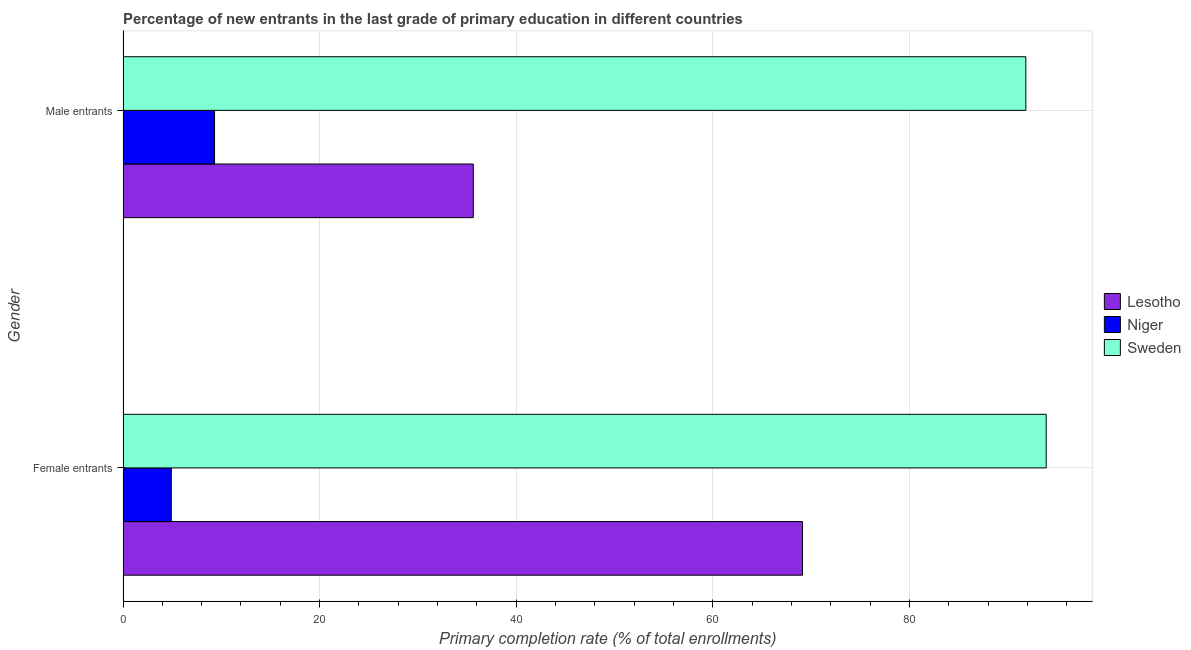How many different coloured bars are there?
Provide a short and direct response. 3. How many groups of bars are there?
Your answer should be very brief. 2. Are the number of bars per tick equal to the number of legend labels?
Keep it short and to the point. Yes. Are the number of bars on each tick of the Y-axis equal?
Provide a short and direct response. Yes. How many bars are there on the 2nd tick from the top?
Make the answer very short. 3. How many bars are there on the 1st tick from the bottom?
Give a very brief answer. 3. What is the label of the 1st group of bars from the top?
Provide a short and direct response. Male entrants. What is the primary completion rate of male entrants in Niger?
Make the answer very short. 9.31. Across all countries, what is the maximum primary completion rate of male entrants?
Ensure brevity in your answer.  91.83. Across all countries, what is the minimum primary completion rate of female entrants?
Your response must be concise. 4.91. In which country was the primary completion rate of male entrants maximum?
Offer a terse response. Sweden. In which country was the primary completion rate of female entrants minimum?
Give a very brief answer. Niger. What is the total primary completion rate of female entrants in the graph?
Make the answer very short. 167.92. What is the difference between the primary completion rate of male entrants in Lesotho and that in Niger?
Your answer should be compact. 26.32. What is the difference between the primary completion rate of female entrants in Sweden and the primary completion rate of male entrants in Niger?
Your answer should be very brief. 84.59. What is the average primary completion rate of female entrants per country?
Your answer should be compact. 55.97. What is the difference between the primary completion rate of female entrants and primary completion rate of male entrants in Sweden?
Provide a short and direct response. 2.07. In how many countries, is the primary completion rate of male entrants greater than 60 %?
Provide a short and direct response. 1. What is the ratio of the primary completion rate of female entrants in Lesotho to that in Sweden?
Keep it short and to the point. 0.74. What does the 1st bar from the top in Female entrants represents?
Provide a succinct answer. Sweden. What does the 2nd bar from the bottom in Male entrants represents?
Your answer should be compact. Niger. How many bars are there?
Provide a succinct answer. 6. What is the difference between two consecutive major ticks on the X-axis?
Your answer should be compact. 20. Are the values on the major ticks of X-axis written in scientific E-notation?
Give a very brief answer. No. How are the legend labels stacked?
Your response must be concise. Vertical. What is the title of the graph?
Your response must be concise. Percentage of new entrants in the last grade of primary education in different countries. What is the label or title of the X-axis?
Offer a terse response. Primary completion rate (% of total enrollments). What is the Primary completion rate (% of total enrollments) in Lesotho in Female entrants?
Keep it short and to the point. 69.11. What is the Primary completion rate (% of total enrollments) of Niger in Female entrants?
Offer a very short reply. 4.91. What is the Primary completion rate (% of total enrollments) of Sweden in Female entrants?
Make the answer very short. 93.9. What is the Primary completion rate (% of total enrollments) in Lesotho in Male entrants?
Provide a short and direct response. 35.63. What is the Primary completion rate (% of total enrollments) in Niger in Male entrants?
Offer a terse response. 9.31. What is the Primary completion rate (% of total enrollments) in Sweden in Male entrants?
Your answer should be compact. 91.83. Across all Gender, what is the maximum Primary completion rate (% of total enrollments) of Lesotho?
Your answer should be very brief. 69.11. Across all Gender, what is the maximum Primary completion rate (% of total enrollments) in Niger?
Offer a very short reply. 9.31. Across all Gender, what is the maximum Primary completion rate (% of total enrollments) of Sweden?
Your response must be concise. 93.9. Across all Gender, what is the minimum Primary completion rate (% of total enrollments) of Lesotho?
Provide a succinct answer. 35.63. Across all Gender, what is the minimum Primary completion rate (% of total enrollments) of Niger?
Keep it short and to the point. 4.91. Across all Gender, what is the minimum Primary completion rate (% of total enrollments) of Sweden?
Your response must be concise. 91.83. What is the total Primary completion rate (% of total enrollments) in Lesotho in the graph?
Give a very brief answer. 104.74. What is the total Primary completion rate (% of total enrollments) of Niger in the graph?
Provide a short and direct response. 14.22. What is the total Primary completion rate (% of total enrollments) of Sweden in the graph?
Your response must be concise. 185.73. What is the difference between the Primary completion rate (% of total enrollments) in Lesotho in Female entrants and that in Male entrants?
Give a very brief answer. 33.48. What is the difference between the Primary completion rate (% of total enrollments) in Niger in Female entrants and that in Male entrants?
Give a very brief answer. -4.4. What is the difference between the Primary completion rate (% of total enrollments) in Sweden in Female entrants and that in Male entrants?
Keep it short and to the point. 2.07. What is the difference between the Primary completion rate (% of total enrollments) of Lesotho in Female entrants and the Primary completion rate (% of total enrollments) of Niger in Male entrants?
Give a very brief answer. 59.8. What is the difference between the Primary completion rate (% of total enrollments) in Lesotho in Female entrants and the Primary completion rate (% of total enrollments) in Sweden in Male entrants?
Offer a very short reply. -22.71. What is the difference between the Primary completion rate (% of total enrollments) in Niger in Female entrants and the Primary completion rate (% of total enrollments) in Sweden in Male entrants?
Make the answer very short. -86.91. What is the average Primary completion rate (% of total enrollments) of Lesotho per Gender?
Provide a succinct answer. 52.37. What is the average Primary completion rate (% of total enrollments) of Niger per Gender?
Your answer should be very brief. 7.11. What is the average Primary completion rate (% of total enrollments) of Sweden per Gender?
Ensure brevity in your answer.  92.86. What is the difference between the Primary completion rate (% of total enrollments) of Lesotho and Primary completion rate (% of total enrollments) of Niger in Female entrants?
Provide a succinct answer. 64.2. What is the difference between the Primary completion rate (% of total enrollments) in Lesotho and Primary completion rate (% of total enrollments) in Sweden in Female entrants?
Offer a terse response. -24.79. What is the difference between the Primary completion rate (% of total enrollments) in Niger and Primary completion rate (% of total enrollments) in Sweden in Female entrants?
Make the answer very short. -88.99. What is the difference between the Primary completion rate (% of total enrollments) in Lesotho and Primary completion rate (% of total enrollments) in Niger in Male entrants?
Offer a very short reply. 26.32. What is the difference between the Primary completion rate (% of total enrollments) of Lesotho and Primary completion rate (% of total enrollments) of Sweden in Male entrants?
Keep it short and to the point. -56.2. What is the difference between the Primary completion rate (% of total enrollments) of Niger and Primary completion rate (% of total enrollments) of Sweden in Male entrants?
Your answer should be compact. -82.52. What is the ratio of the Primary completion rate (% of total enrollments) of Lesotho in Female entrants to that in Male entrants?
Offer a terse response. 1.94. What is the ratio of the Primary completion rate (% of total enrollments) of Niger in Female entrants to that in Male entrants?
Your answer should be very brief. 0.53. What is the ratio of the Primary completion rate (% of total enrollments) of Sweden in Female entrants to that in Male entrants?
Provide a short and direct response. 1.02. What is the difference between the highest and the second highest Primary completion rate (% of total enrollments) in Lesotho?
Give a very brief answer. 33.48. What is the difference between the highest and the second highest Primary completion rate (% of total enrollments) in Niger?
Provide a succinct answer. 4.4. What is the difference between the highest and the second highest Primary completion rate (% of total enrollments) of Sweden?
Give a very brief answer. 2.07. What is the difference between the highest and the lowest Primary completion rate (% of total enrollments) of Lesotho?
Ensure brevity in your answer.  33.48. What is the difference between the highest and the lowest Primary completion rate (% of total enrollments) in Niger?
Provide a succinct answer. 4.4. What is the difference between the highest and the lowest Primary completion rate (% of total enrollments) of Sweden?
Keep it short and to the point. 2.07. 